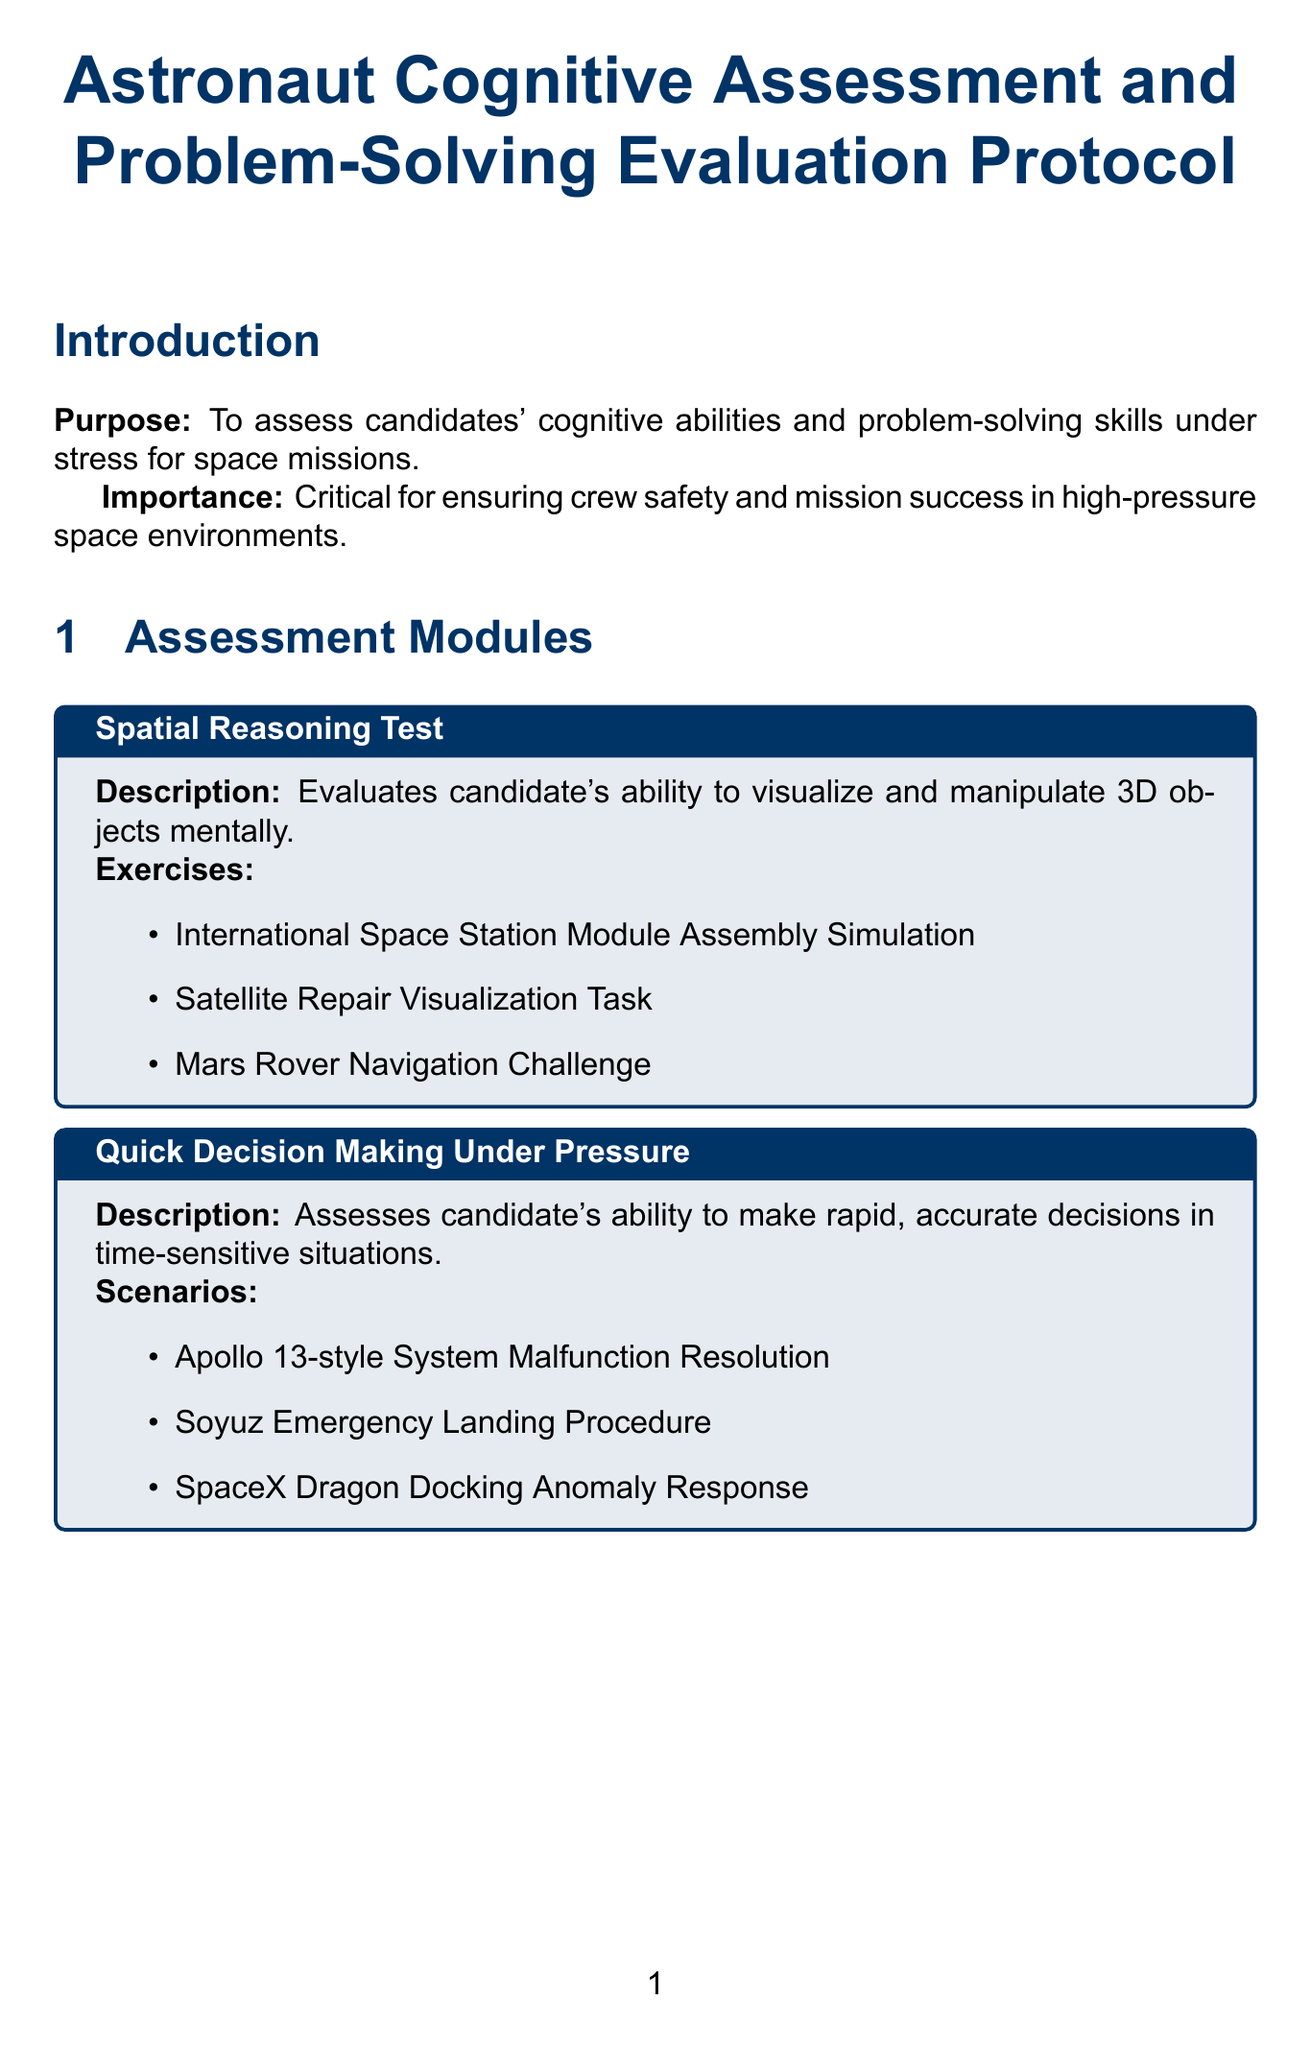What is the title of the manual? The title of the manual is featured prominently at the top of the document.
Answer: Astronaut Cognitive Assessment and Problem-Solving Evaluation Protocol How many assessment modules are there? The number of assessment modules is listed in the document's introduction section.
Answer: Four What is the first exercise in the Spatial Reasoning Test module? The first exercise is part of the list of exercises in the Spatial Reasoning Test module.
Answer: International Space Station Module Assembly Simulation What physiological measurements are used in stress management evaluation? The document specifies which physiological measurements are included in evaluating stress management criteria.
Answer: Heart rate, cortisol levels Which simulation environment replicates the NASA's Mission Control Center? This information is found under the simulation environments section.
Answer: Mission Control Replica What criterion measures the correctness of decisions? The document provides descriptions of various evaluation criteria, including this one.
Answer: Accuracy What type of software is mentioned in the debriefing protocol tools? It lists specific tools used as part of the assessment process.
Answer: Performance analytics software Name one scenario from the Quick Decision Making Under Pressure module. Specific scenarios are listed in the Quick Decision Making Under Pressure module.
Answer: Apollo 13-style System Malfunction Resolution Who is part of the expert panel composition? The composition of the expert panel is detailed in the expert panel section.
Answer: Experienced astronauts What is the main purpose of the assessment protocol? The purpose is stated in the introduction of the document.
Answer: To assess candidates' cognitive abilities and problem-solving skills under stress for space missions 